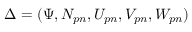Convert formula to latex. <formula><loc_0><loc_0><loc_500><loc_500>\Delta = ( \Psi , N _ { p n } , U _ { p n } , V _ { p n } , W _ { p n } )</formula> 